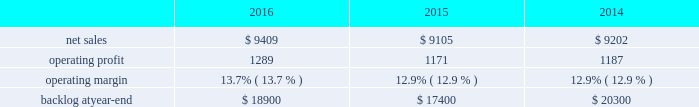Segment includes awe and our share of earnings for our investment in ula , which provides expendable launch services to the u.s .
Government .
Space systems 2019 operating results included the following ( in millions ) : .
2016 compared to 2015 space systems 2019 net sales in 2016 increased $ 304 million , or 3% ( 3 % ) , compared to 2015 .
The increase was attributable to net sales of approximately $ 410 million from awe following the consolidation of this business in the third quarter of 2016 ; and approximately $ 150 million for commercial space transportation programs due to increased launch-related activities ; and approximately $ 70 million of higher net sales for various programs ( primarily fleet ballistic missiles ) due to increased volume .
These increases were partially offset by a decrease in net sales of approximately $ 340 million for government satellite programs due to decreased volume ( primarily sbirs and muos ) and the wind-down or completion of mission solutions programs .
Space systems 2019 operating profit in 2016 increased $ 118 million , or 10% ( 10 % ) , compared to 2015 .
The increase was primarily attributable to a non-cash , pre-tax gain of approximately $ 127 million related to the consolidation of awe ; and approximately $ 80 million of increased equity earnings from joint ventures ( primarily ula ) .
These increases were partially offset by a decrease of approximately $ 105 million for government satellite programs due to lower risk retirements ( primarily sbirs , muos and mission solutions programs ) and decreased volume .
Adjustments not related to volume , including net profit booking rate adjustments , were approximately $ 185 million lower in 2016 compared to 2015 .
2015 compared to 2014 space systems 2019 net sales in 2015 decreased $ 97 million , or 1% ( 1 % ) , compared to 2014 .
The decrease was attributable to approximately $ 335 million lower net sales for government satellite programs due to decreased volume ( primarily aehf ) and the wind-down or completion of mission solutions programs ; and approximately $ 55 million for strategic missile and defense systems due to lower volume .
These decreases were partially offset by higher net sales of approximately $ 235 million for businesses acquired in 2014 ; and approximately $ 75 million for the orion program due to increased volume .
Space systems 2019 operating profit in 2015 decreased $ 16 million , or 1% ( 1 % ) , compared to 2014 .
Operating profit increased approximately $ 85 million for government satellite programs due primarily to increased risk retirements .
This increase was offset by lower operating profit of approximately $ 65 million for commercial satellite programs due to performance matters on certain programs ; and approximately $ 35 million due to decreased equity earnings in joint ventures .
Adjustments not related to volume , including net profit booking rate adjustments and other matters , were approximately $ 105 million higher in 2015 compared to 2014 .
Equity earnings total equity earnings recognized by space systems ( primarily ula ) represented approximately $ 325 million , $ 245 million and $ 280 million , or 25% ( 25 % ) , 21% ( 21 % ) and 24% ( 24 % ) of this business segment 2019s operating profit during 2016 , 2015 and backlog backlog increased in 2016 compared to 2015 primarily due to the addition of awe 2019s backlog .
Backlog decreased in 2015 compared to 2014 primarily due to lower orders for government satellite programs and the orion program and higher sales on the orion program .
Trends we expect space systems 2019 2017 net sales to decrease in the mid-single digit percentage range as compared to 2016 , driven by program lifecycles on government satellite programs , partially offset by the recognition of awe net sales for a full year in 2017 versus a partial year in 2016 following the consolidation of awe in the third quarter of 2016 .
Operating profit .
What is the growth rate for backlog at year-end from 2015 to 2016? 
Computations: ((18900 - 17400) / 17400)
Answer: 0.08621. 